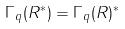Convert formula to latex. <formula><loc_0><loc_0><loc_500><loc_500>\Gamma _ { q } ( R ^ { * } ) = \Gamma _ { q } ( R ) ^ { * }</formula> 